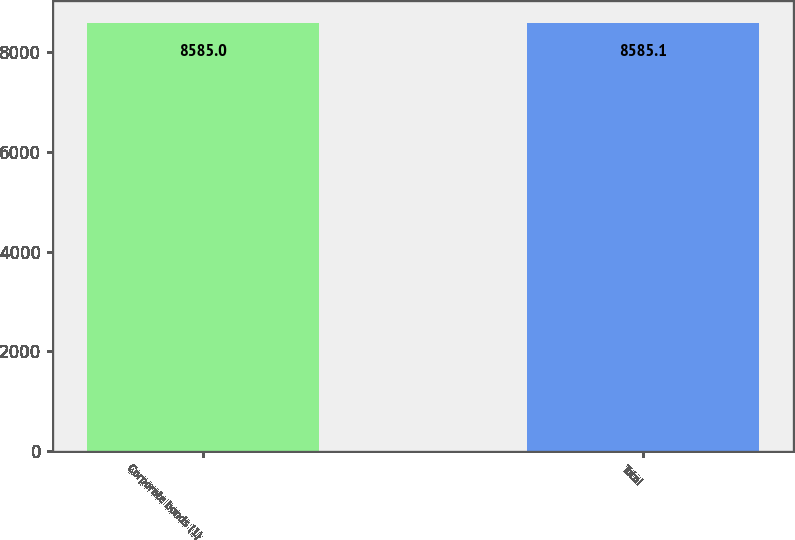Convert chart to OTSL. <chart><loc_0><loc_0><loc_500><loc_500><bar_chart><fcel>Corporate bonds (1)<fcel>Total<nl><fcel>8585<fcel>8585.1<nl></chart> 